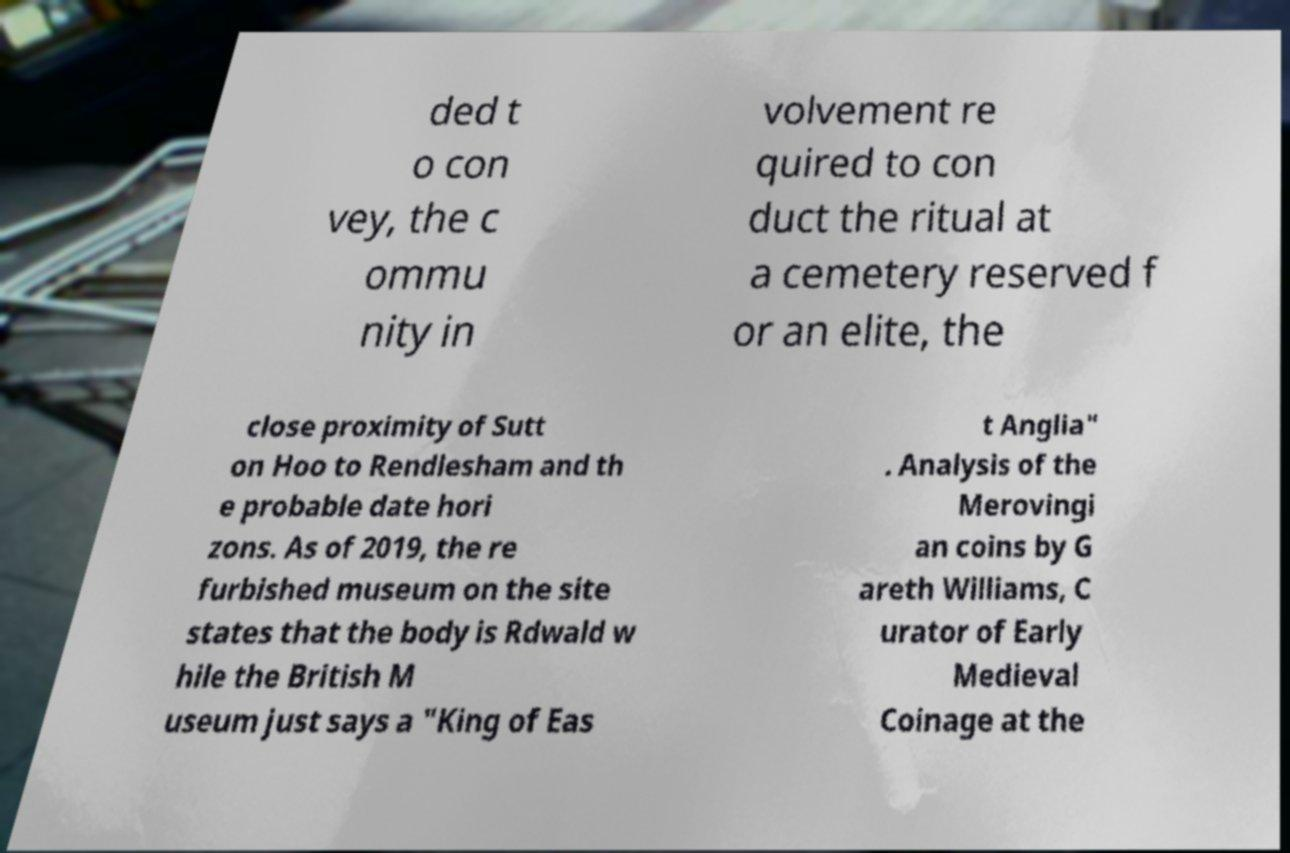Could you assist in decoding the text presented in this image and type it out clearly? ded t o con vey, the c ommu nity in volvement re quired to con duct the ritual at a cemetery reserved f or an elite, the close proximity of Sutt on Hoo to Rendlesham and th e probable date hori zons. As of 2019, the re furbished museum on the site states that the body is Rdwald w hile the British M useum just says a "King of Eas t Anglia" . Analysis of the Merovingi an coins by G areth Williams, C urator of Early Medieval Coinage at the 